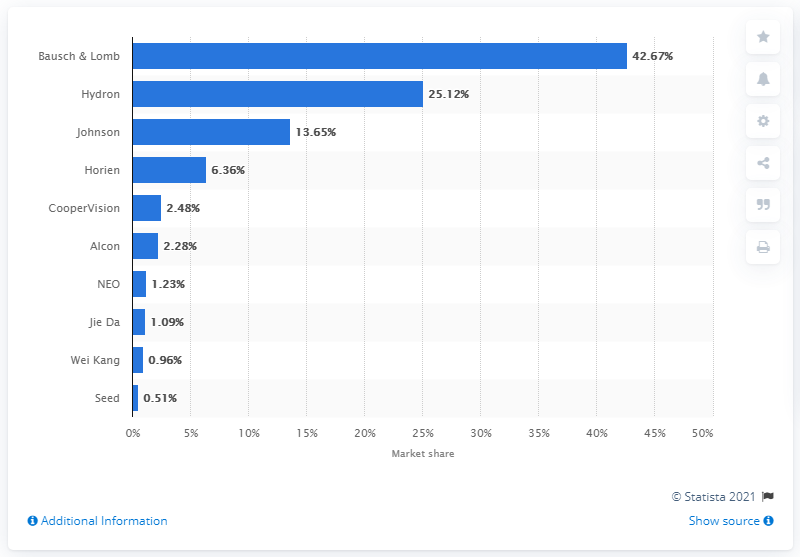Specify some key components in this picture. Bausch & Lomb was the largest contact lens retailer on JD.com. 